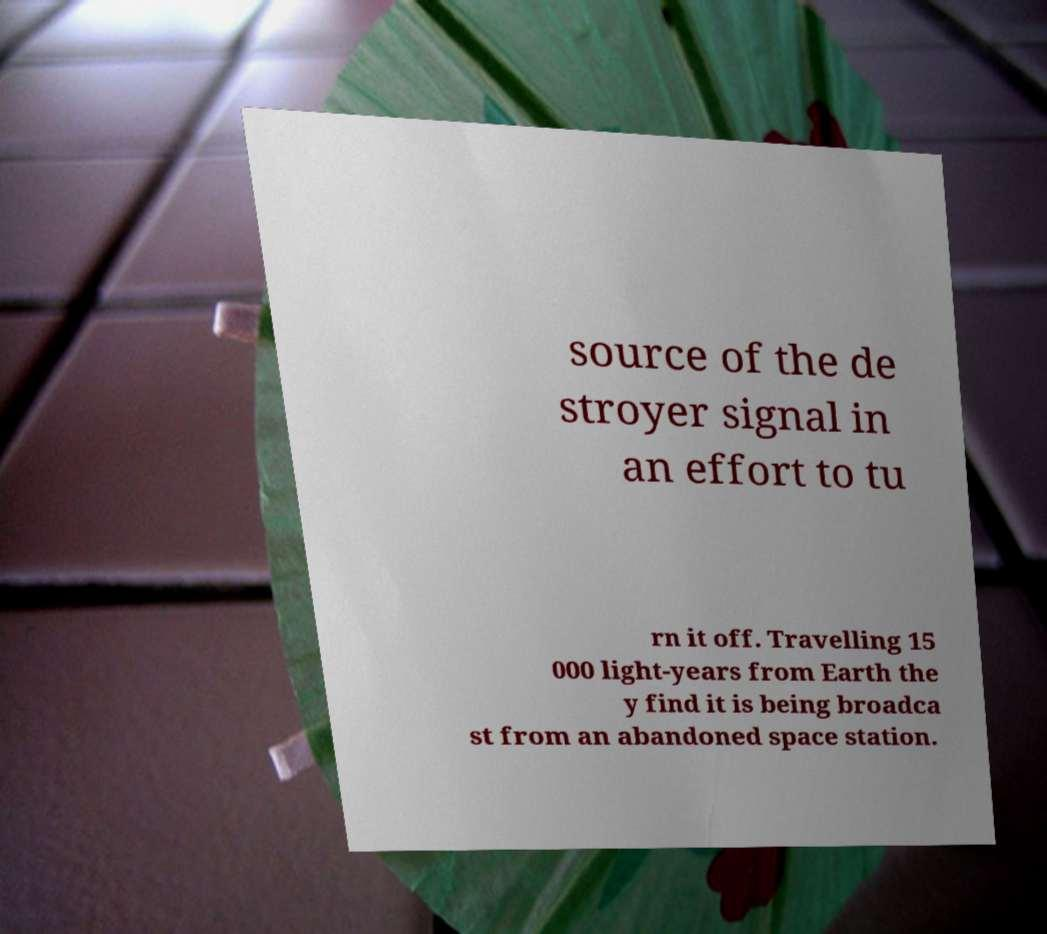For documentation purposes, I need the text within this image transcribed. Could you provide that? source of the de stroyer signal in an effort to tu rn it off. Travelling 15 000 light-years from Earth the y find it is being broadca st from an abandoned space station. 